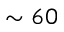Convert formula to latex. <formula><loc_0><loc_0><loc_500><loc_500>\sim 6 0</formula> 